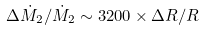Convert formula to latex. <formula><loc_0><loc_0><loc_500><loc_500>\Delta \dot { M } _ { 2 } / \dot { M } _ { 2 } \sim 3 2 0 0 \times \Delta R / R</formula> 